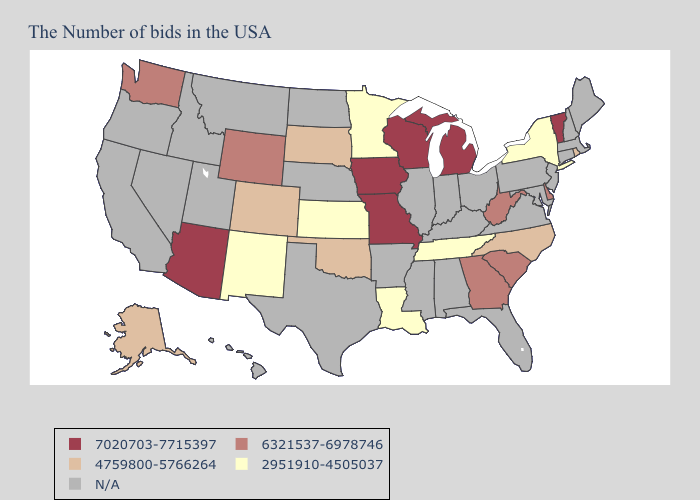Which states have the lowest value in the South?
Concise answer only. Tennessee, Louisiana. Name the states that have a value in the range 2951910-4505037?
Quick response, please. New York, Tennessee, Louisiana, Minnesota, Kansas, New Mexico. Does New York have the highest value in the Northeast?
Give a very brief answer. No. Does Delaware have the lowest value in the USA?
Quick response, please. No. Name the states that have a value in the range 2951910-4505037?
Give a very brief answer. New York, Tennessee, Louisiana, Minnesota, Kansas, New Mexico. Name the states that have a value in the range 4759800-5766264?
Concise answer only. Rhode Island, North Carolina, Oklahoma, South Dakota, Colorado, Alaska. Name the states that have a value in the range N/A?
Concise answer only. Maine, Massachusetts, New Hampshire, Connecticut, New Jersey, Maryland, Pennsylvania, Virginia, Ohio, Florida, Kentucky, Indiana, Alabama, Illinois, Mississippi, Arkansas, Nebraska, Texas, North Dakota, Utah, Montana, Idaho, Nevada, California, Oregon, Hawaii. Does South Dakota have the highest value in the MidWest?
Keep it brief. No. What is the value of Utah?
Short answer required. N/A. How many symbols are there in the legend?
Short answer required. 5. What is the lowest value in the MidWest?
Be succinct. 2951910-4505037. What is the value of Florida?
Give a very brief answer. N/A. 